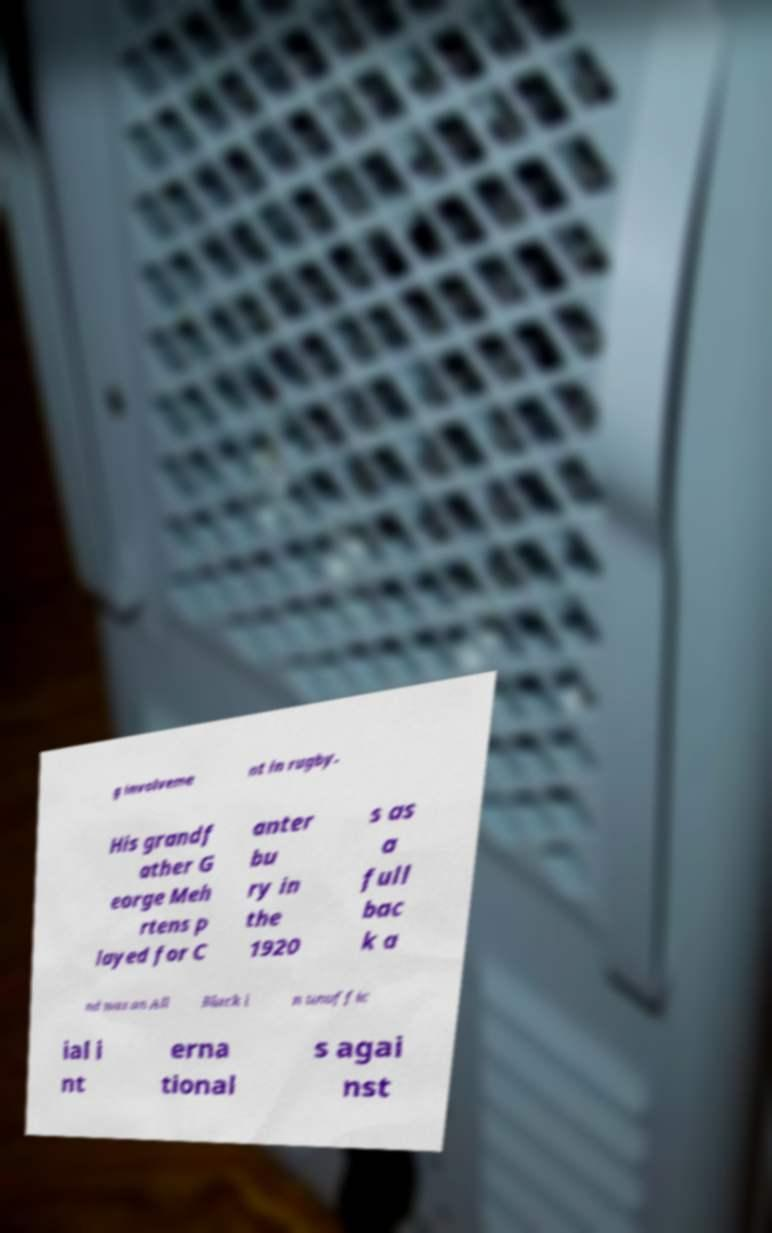I need the written content from this picture converted into text. Can you do that? g involveme nt in rugby. His grandf ather G eorge Meh rtens p layed for C anter bu ry in the 1920 s as a full bac k a nd was an All Black i n unoffic ial i nt erna tional s agai nst 